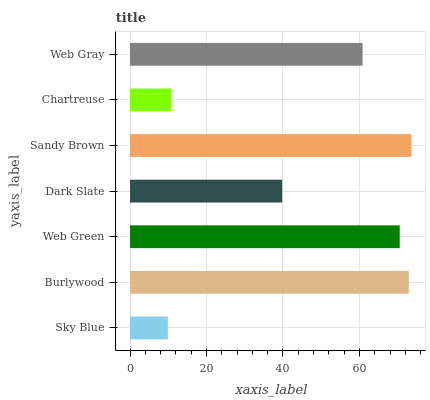Is Sky Blue the minimum?
Answer yes or no. Yes. Is Sandy Brown the maximum?
Answer yes or no. Yes. Is Burlywood the minimum?
Answer yes or no. No. Is Burlywood the maximum?
Answer yes or no. No. Is Burlywood greater than Sky Blue?
Answer yes or no. Yes. Is Sky Blue less than Burlywood?
Answer yes or no. Yes. Is Sky Blue greater than Burlywood?
Answer yes or no. No. Is Burlywood less than Sky Blue?
Answer yes or no. No. Is Web Gray the high median?
Answer yes or no. Yes. Is Web Gray the low median?
Answer yes or no. Yes. Is Sandy Brown the high median?
Answer yes or no. No. Is Web Green the low median?
Answer yes or no. No. 